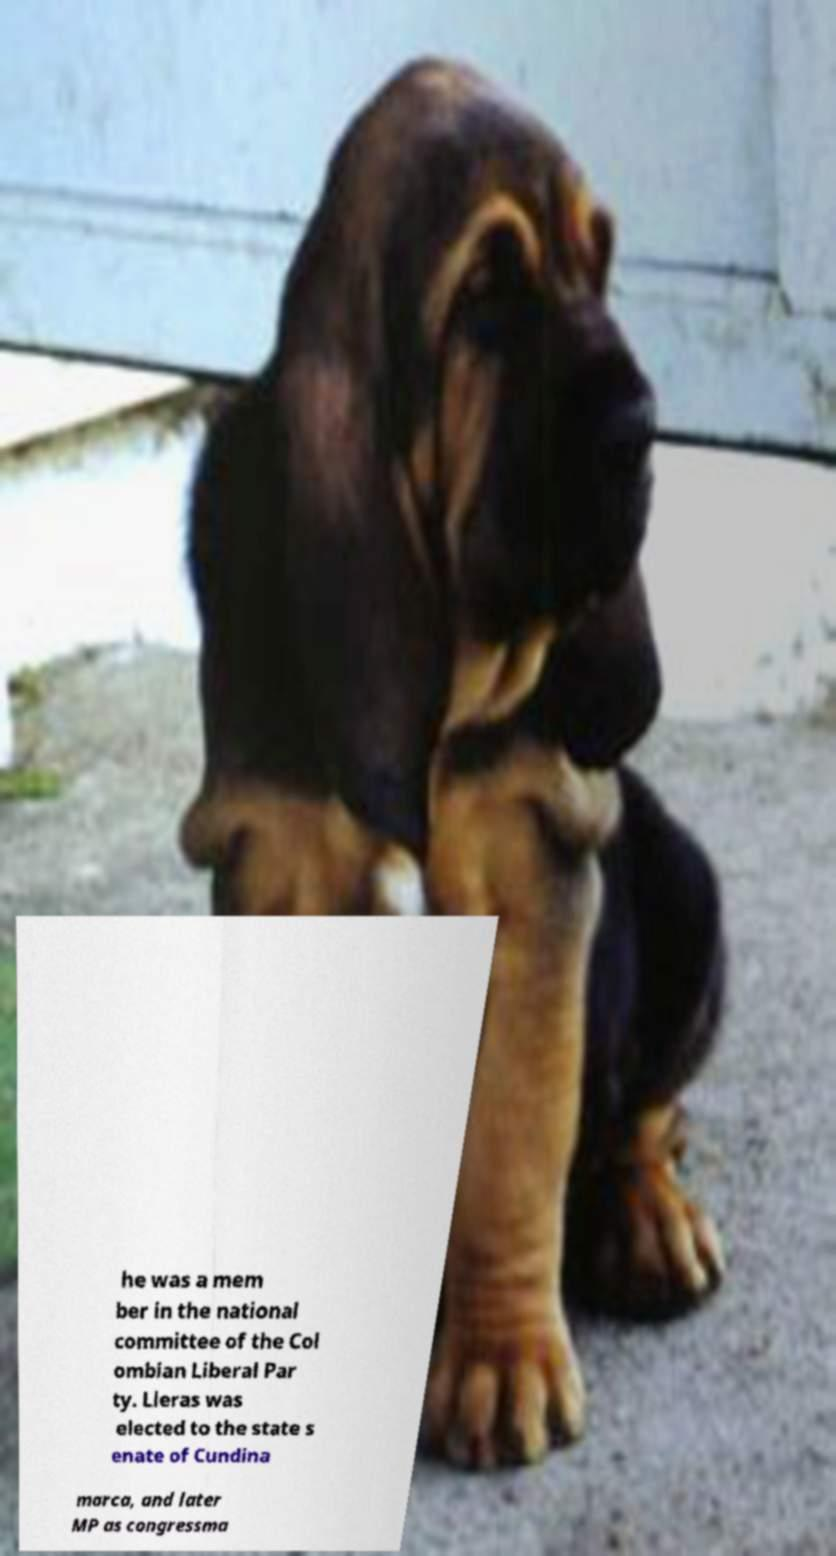For documentation purposes, I need the text within this image transcribed. Could you provide that? he was a mem ber in the national committee of the Col ombian Liberal Par ty. Lleras was elected to the state s enate of Cundina marca, and later MP as congressma 